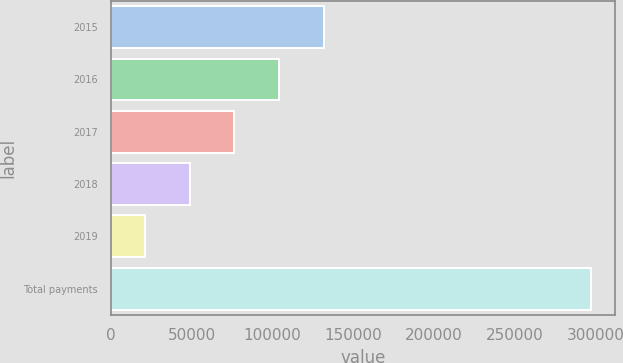Convert chart to OTSL. <chart><loc_0><loc_0><loc_500><loc_500><bar_chart><fcel>2015<fcel>2016<fcel>2017<fcel>2018<fcel>2019<fcel>Total payments<nl><fcel>131543<fcel>103948<fcel>76353.6<fcel>48758.8<fcel>21164<fcel>297112<nl></chart> 